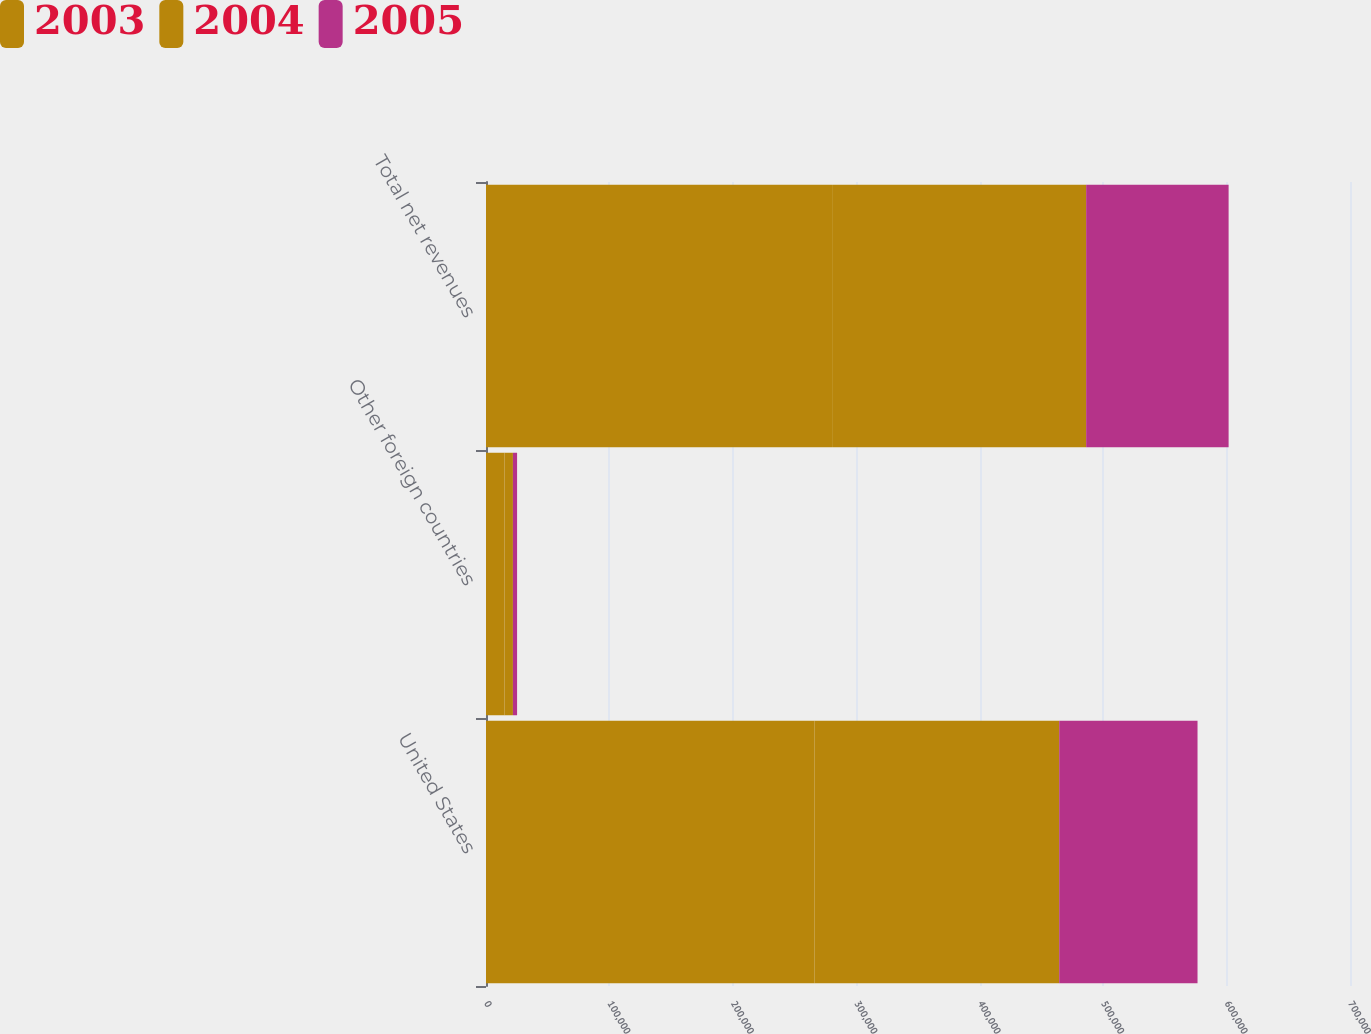Convert chart to OTSL. <chart><loc_0><loc_0><loc_500><loc_500><stacked_bar_chart><ecel><fcel>United States<fcel>Other foreign countries<fcel>Total net revenues<nl><fcel>2003<fcel>266048<fcel>15005<fcel>281053<nl><fcel>2004<fcel>198368<fcel>6813<fcel>205181<nl><fcel>2005<fcel>112052<fcel>3367<fcel>115419<nl></chart> 